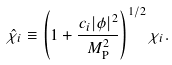Convert formula to latex. <formula><loc_0><loc_0><loc_500><loc_500>\hat { \chi } _ { i } \equiv \left ( 1 + \frac { c _ { i } | \phi | ^ { 2 } } { M _ { \text {P} } ^ { 2 } } \right ) ^ { 1 / 2 } \chi _ { i } .</formula> 